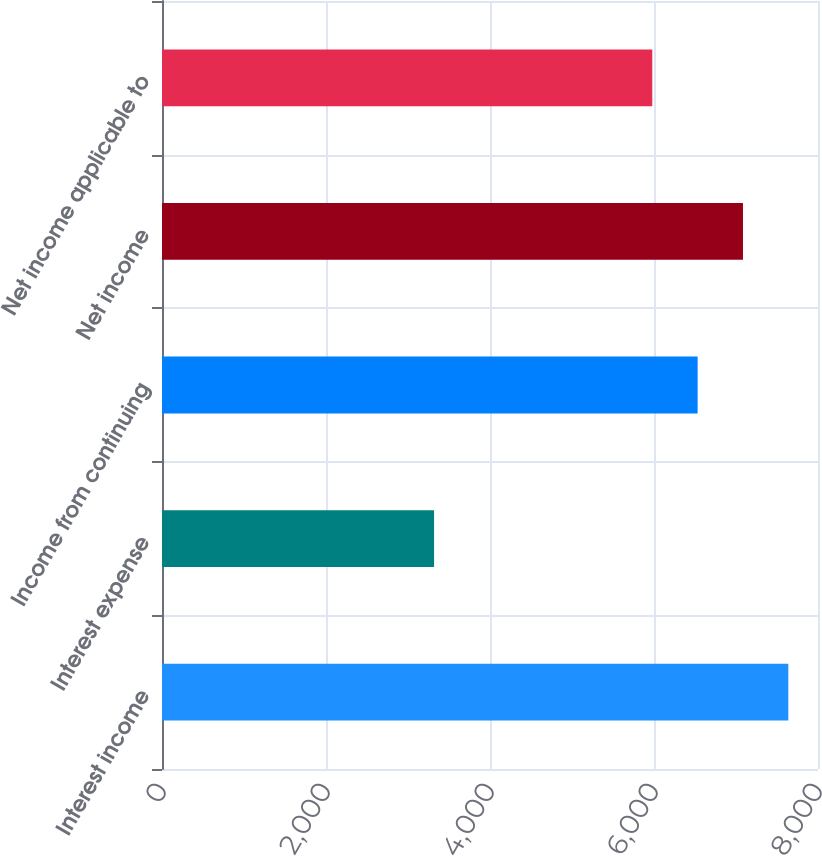Convert chart to OTSL. <chart><loc_0><loc_0><loc_500><loc_500><bar_chart><fcel>Interest income<fcel>Interest expense<fcel>Income from continuing<fcel>Net income<fcel>Net income applicable to<nl><fcel>7638<fcel>3318<fcel>6532<fcel>7085<fcel>5979<nl></chart> 